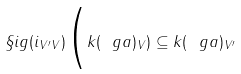Convert formula to latex. <formula><loc_0><loc_0><loc_500><loc_500>\S i g ( i _ { V ^ { \prime } V } ) \Big ( k ( \ g a ) _ { V } ) \subseteq k ( \ g a ) _ { V ^ { \prime } }</formula> 